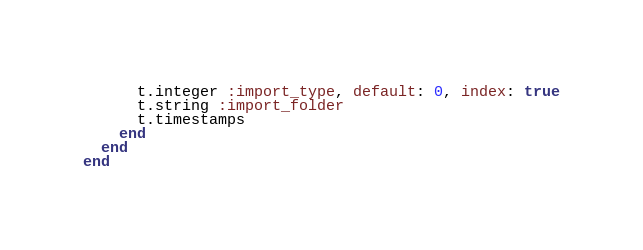Convert code to text. <code><loc_0><loc_0><loc_500><loc_500><_Ruby_>      t.integer :import_type, default: 0, index: true
      t.string :import_folder
      t.timestamps
    end
  end
end
</code> 